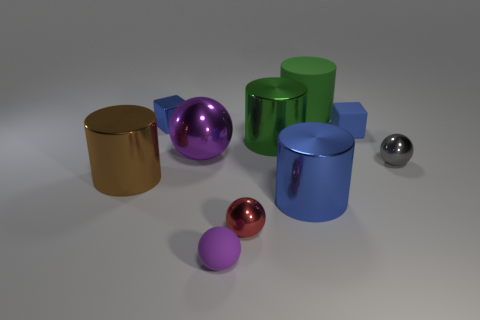Is there a tiny red thing that has the same material as the big brown thing?
Offer a very short reply. Yes. Do the metal block and the rubber cube have the same color?
Keep it short and to the point. Yes. There is a big cylinder that is both in front of the small blue metallic cube and behind the big brown metallic object; what material is it?
Offer a very short reply. Metal. The rubber sphere has what color?
Provide a short and direct response. Purple. What number of small metal objects are the same shape as the large purple metal object?
Keep it short and to the point. 2. Does the gray sphere that is behind the large brown shiny cylinder have the same material as the green cylinder that is in front of the small blue shiny object?
Offer a terse response. Yes. There is a shiny sphere that is to the left of the tiny metal ball left of the blue rubber thing; how big is it?
Provide a short and direct response. Large. There is a small purple object that is the same shape as the gray object; what material is it?
Offer a terse response. Rubber. There is a tiny matte thing that is in front of the small red sphere; is it the same shape as the metal object on the right side of the tiny matte cube?
Your answer should be compact. Yes. Are there more big green matte objects than tiny cyan rubber things?
Ensure brevity in your answer.  Yes. 